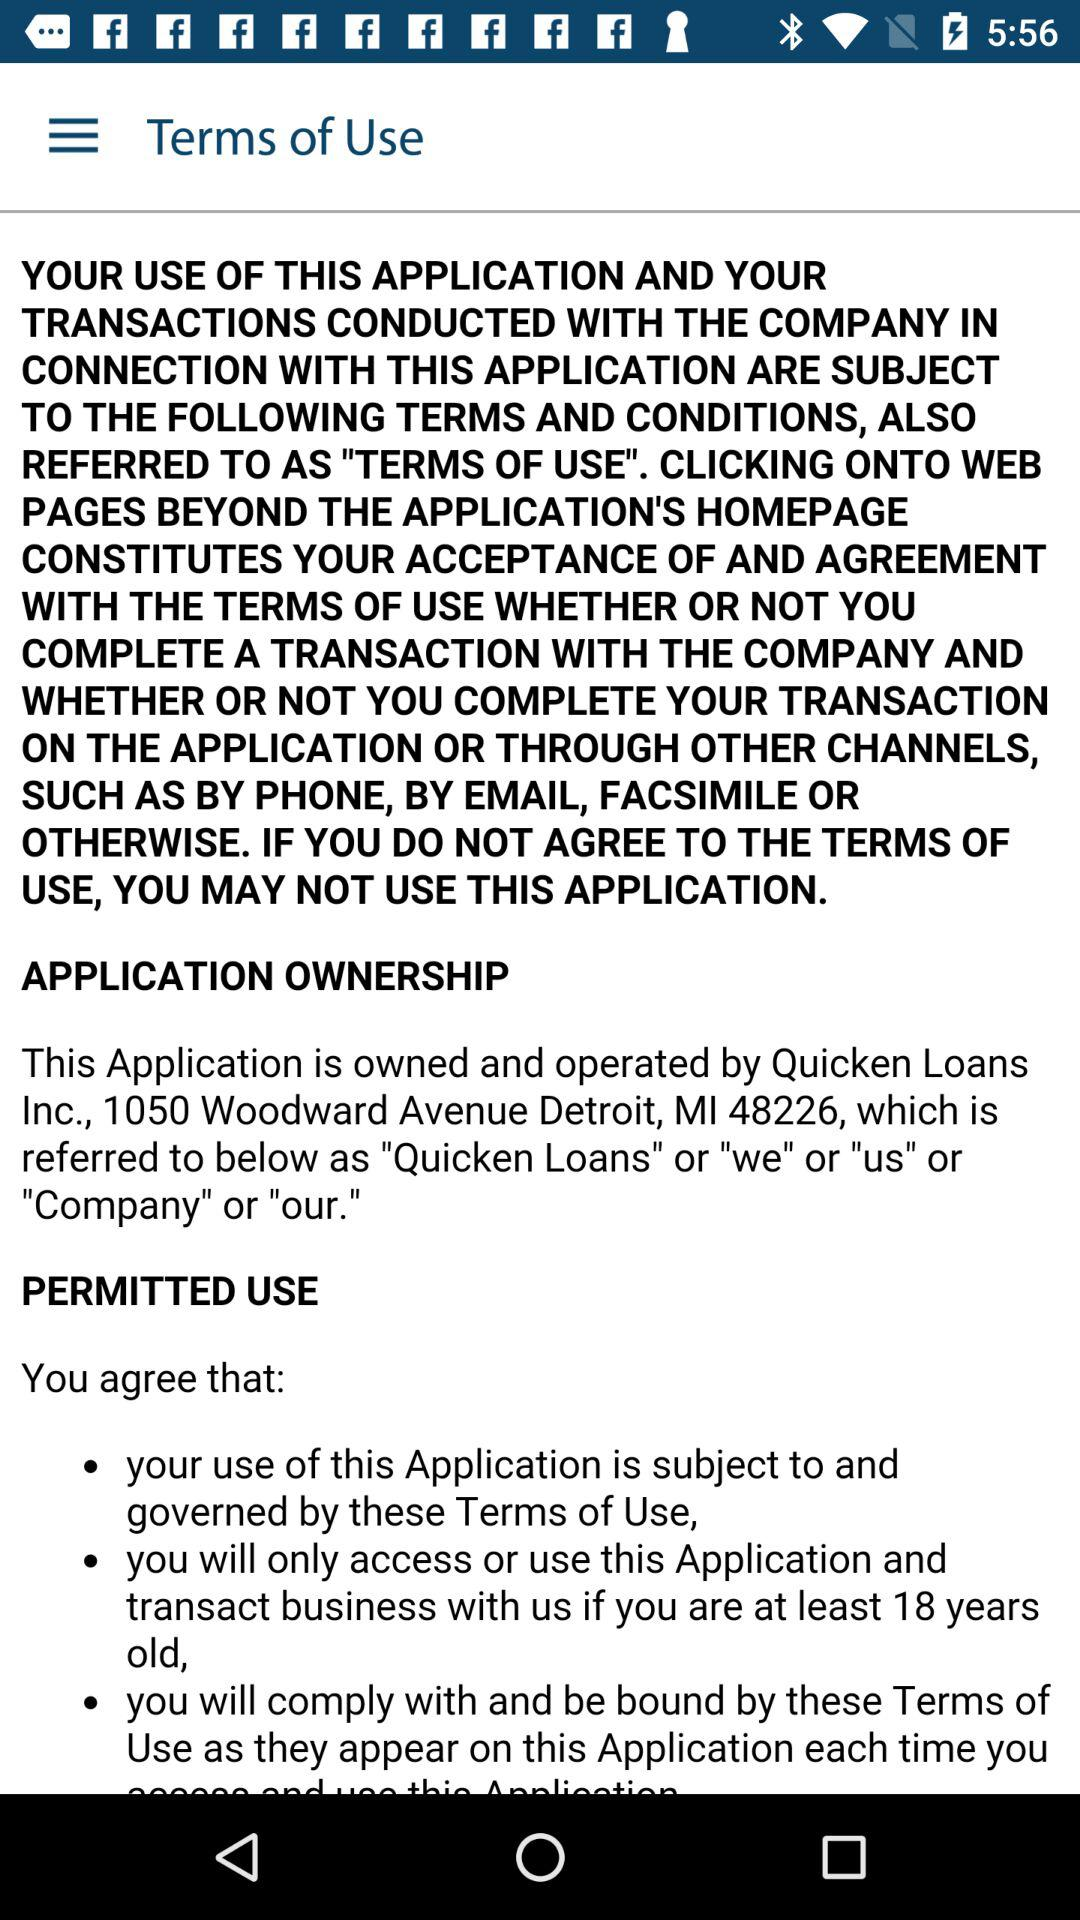How many bullet points are there in the permitted use section?
Answer the question using a single word or phrase. 3 